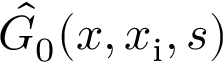<formula> <loc_0><loc_0><loc_500><loc_500>\hat { G } _ { 0 } ( x , x _ { i } , s )</formula> 